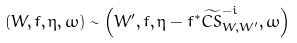Convert formula to latex. <formula><loc_0><loc_0><loc_500><loc_500>( W , f , \eta , \omega ) \sim \left ( W ^ { \prime } , f , \eta - f ^ { * } \widetilde { C S } ^ { - i } _ { W , W ^ { \prime } } , \omega \right )</formula> 